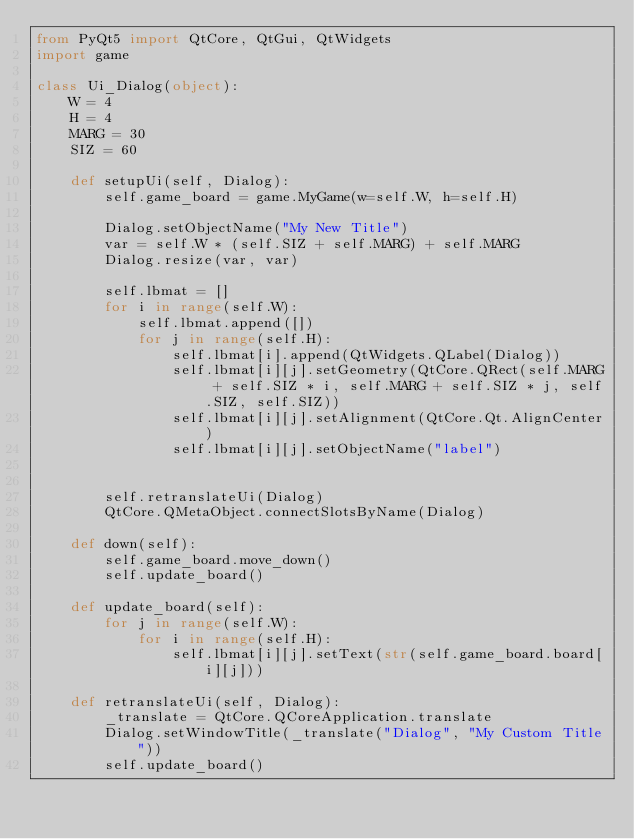Convert code to text. <code><loc_0><loc_0><loc_500><loc_500><_Python_>from PyQt5 import QtCore, QtGui, QtWidgets
import game

class Ui_Dialog(object):
    W = 4
    H = 4
    MARG = 30
    SIZ = 60

    def setupUi(self, Dialog):
        self.game_board = game.MyGame(w=self.W, h=self.H)

        Dialog.setObjectName("My New Title")
        var = self.W * (self.SIZ + self.MARG) + self.MARG
        Dialog.resize(var, var)

        self.lbmat = []
        for i in range(self.W):
            self.lbmat.append([])
            for j in range(self.H):
                self.lbmat[i].append(QtWidgets.QLabel(Dialog))
                self.lbmat[i][j].setGeometry(QtCore.QRect(self.MARG + self.SIZ * i, self.MARG + self.SIZ * j, self.SIZ, self.SIZ))
                self.lbmat[i][j].setAlignment(QtCore.Qt.AlignCenter)
                self.lbmat[i][j].setObjectName("label")


        self.retranslateUi(Dialog)
        QtCore.QMetaObject.connectSlotsByName(Dialog)

    def down(self):
        self.game_board.move_down()
        self.update_board()

    def update_board(self):
        for j in range(self.W):
            for i in range(self.H):
                self.lbmat[i][j].setText(str(self.game_board.board[i][j]))

    def retranslateUi(self, Dialog):
        _translate = QtCore.QCoreApplication.translate
        Dialog.setWindowTitle(_translate("Dialog", "My Custom Title"))
        self.update_board()
</code> 